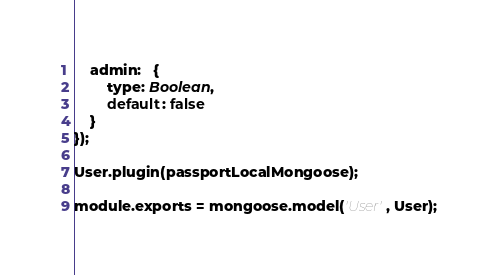Convert code to text. <code><loc_0><loc_0><loc_500><loc_500><_JavaScript_>    admin:   {
        type: Boolean,
        default: false
    }
});

User.plugin(passportLocalMongoose);

module.exports = mongoose.model('User', User);
</code> 